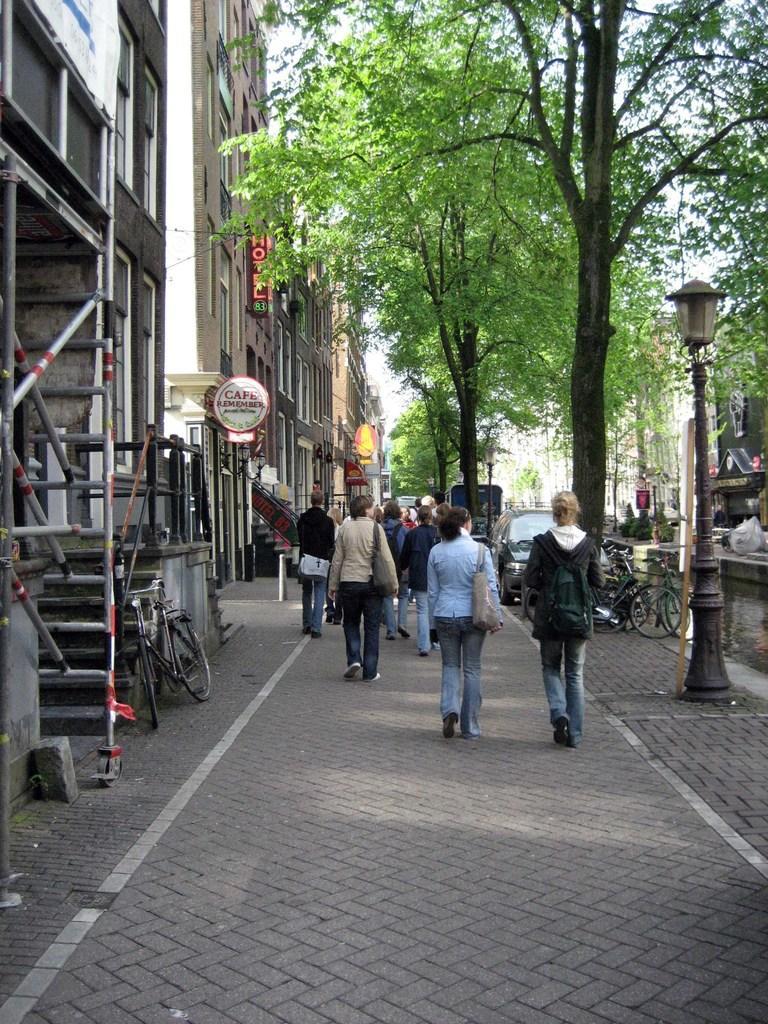Can you describe this image briefly? In this image, we can see a group of people are walking on the footpath. Few people are wearing bags. Here we can see few vehicles, poles, light, trees, buildings, hoardings, rods, walls, windows, banners. Background there is a sky. 